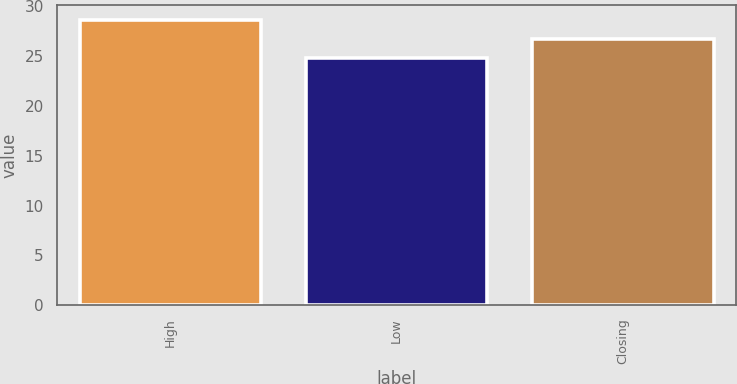Convert chart. <chart><loc_0><loc_0><loc_500><loc_500><bar_chart><fcel>High<fcel>Low<fcel>Closing<nl><fcel>28.67<fcel>24.86<fcel>26.7<nl></chart> 